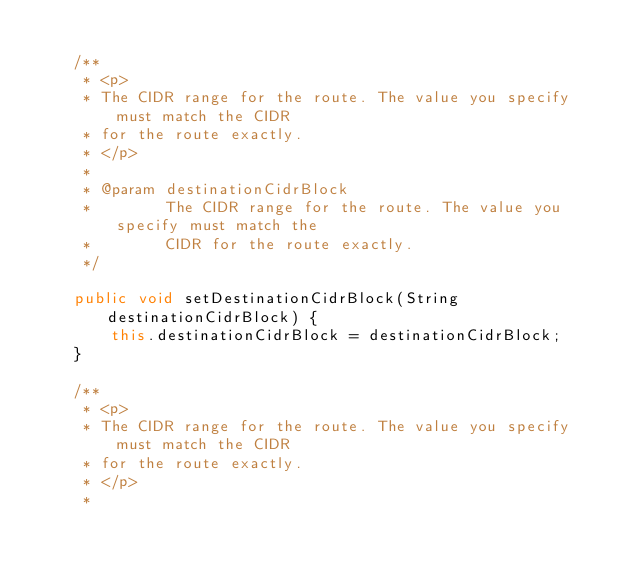<code> <loc_0><loc_0><loc_500><loc_500><_Java_>
    /**
     * <p>
     * The CIDR range for the route. The value you specify must match the CIDR
     * for the route exactly.
     * </p>
     * 
     * @param destinationCidrBlock
     *        The CIDR range for the route. The value you specify must match the
     *        CIDR for the route exactly.
     */

    public void setDestinationCidrBlock(String destinationCidrBlock) {
        this.destinationCidrBlock = destinationCidrBlock;
    }

    /**
     * <p>
     * The CIDR range for the route. The value you specify must match the CIDR
     * for the route exactly.
     * </p>
     * </code> 